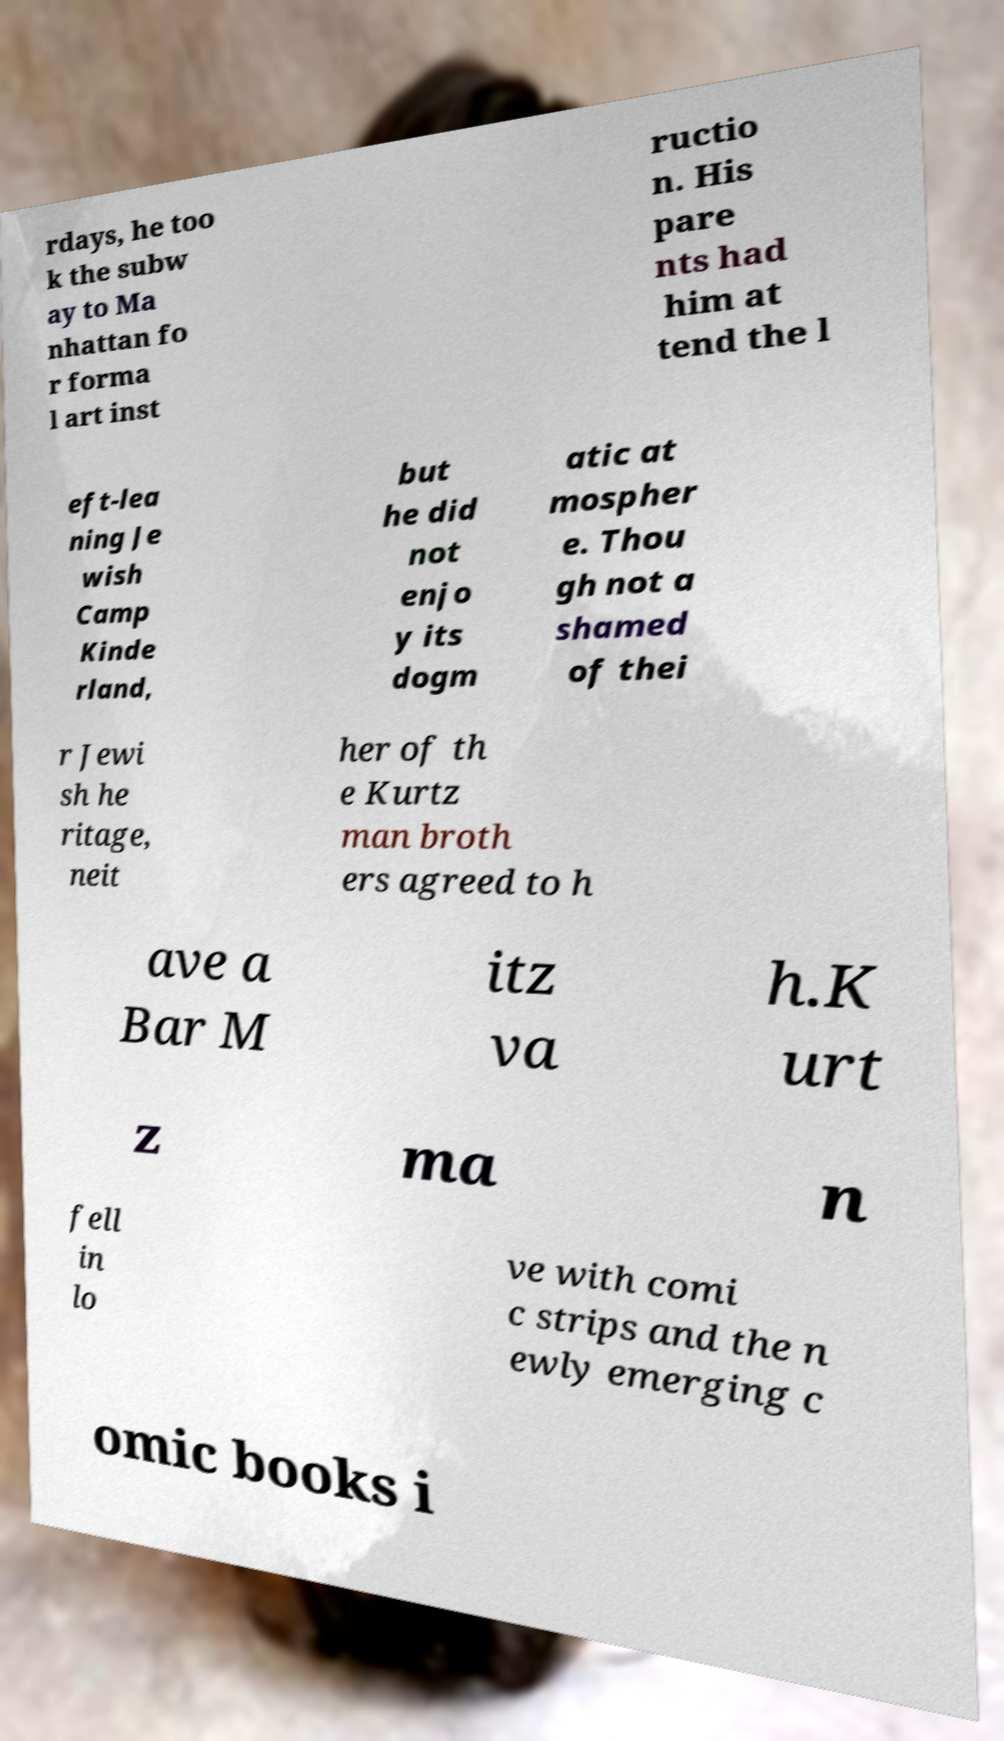I need the written content from this picture converted into text. Can you do that? rdays, he too k the subw ay to Ma nhattan fo r forma l art inst ructio n. His pare nts had him at tend the l eft-lea ning Je wish Camp Kinde rland, but he did not enjo y its dogm atic at mospher e. Thou gh not a shamed of thei r Jewi sh he ritage, neit her of th e Kurtz man broth ers agreed to h ave a Bar M itz va h.K urt z ma n fell in lo ve with comi c strips and the n ewly emerging c omic books i 